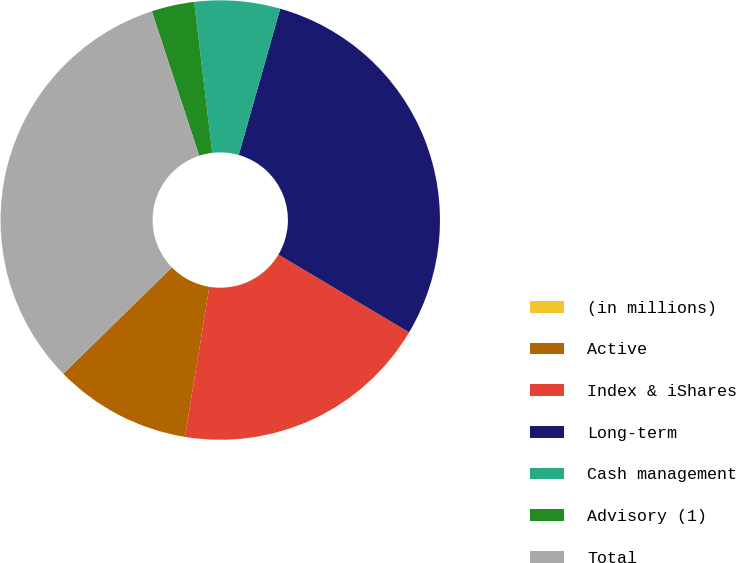Convert chart to OTSL. <chart><loc_0><loc_0><loc_500><loc_500><pie_chart><fcel>(in millions)<fcel>Active<fcel>Index & iShares<fcel>Long-term<fcel>Cash management<fcel>Advisory (1)<fcel>Total<nl><fcel>0.01%<fcel>10.1%<fcel>19.03%<fcel>29.13%<fcel>6.29%<fcel>3.15%<fcel>32.27%<nl></chart> 